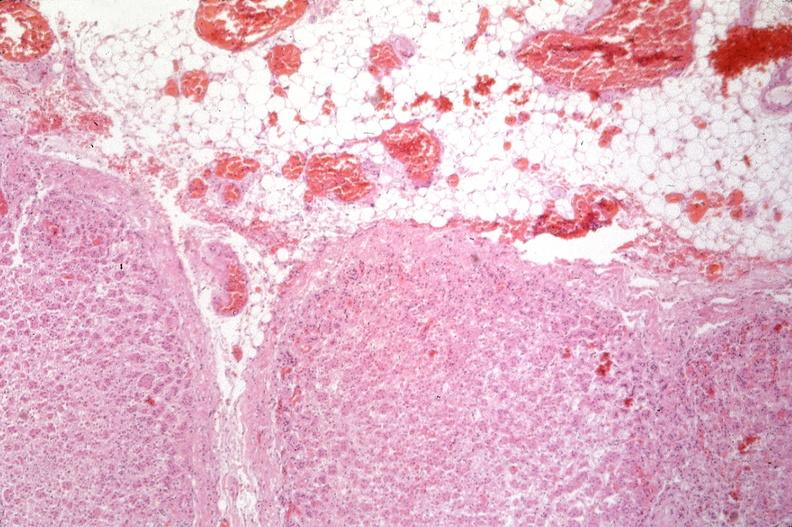does sickle cell disease show pancreas, thrombi and hemorrhage due to disseminated intravascular coagulation dic?
Answer the question using a single word or phrase. No 